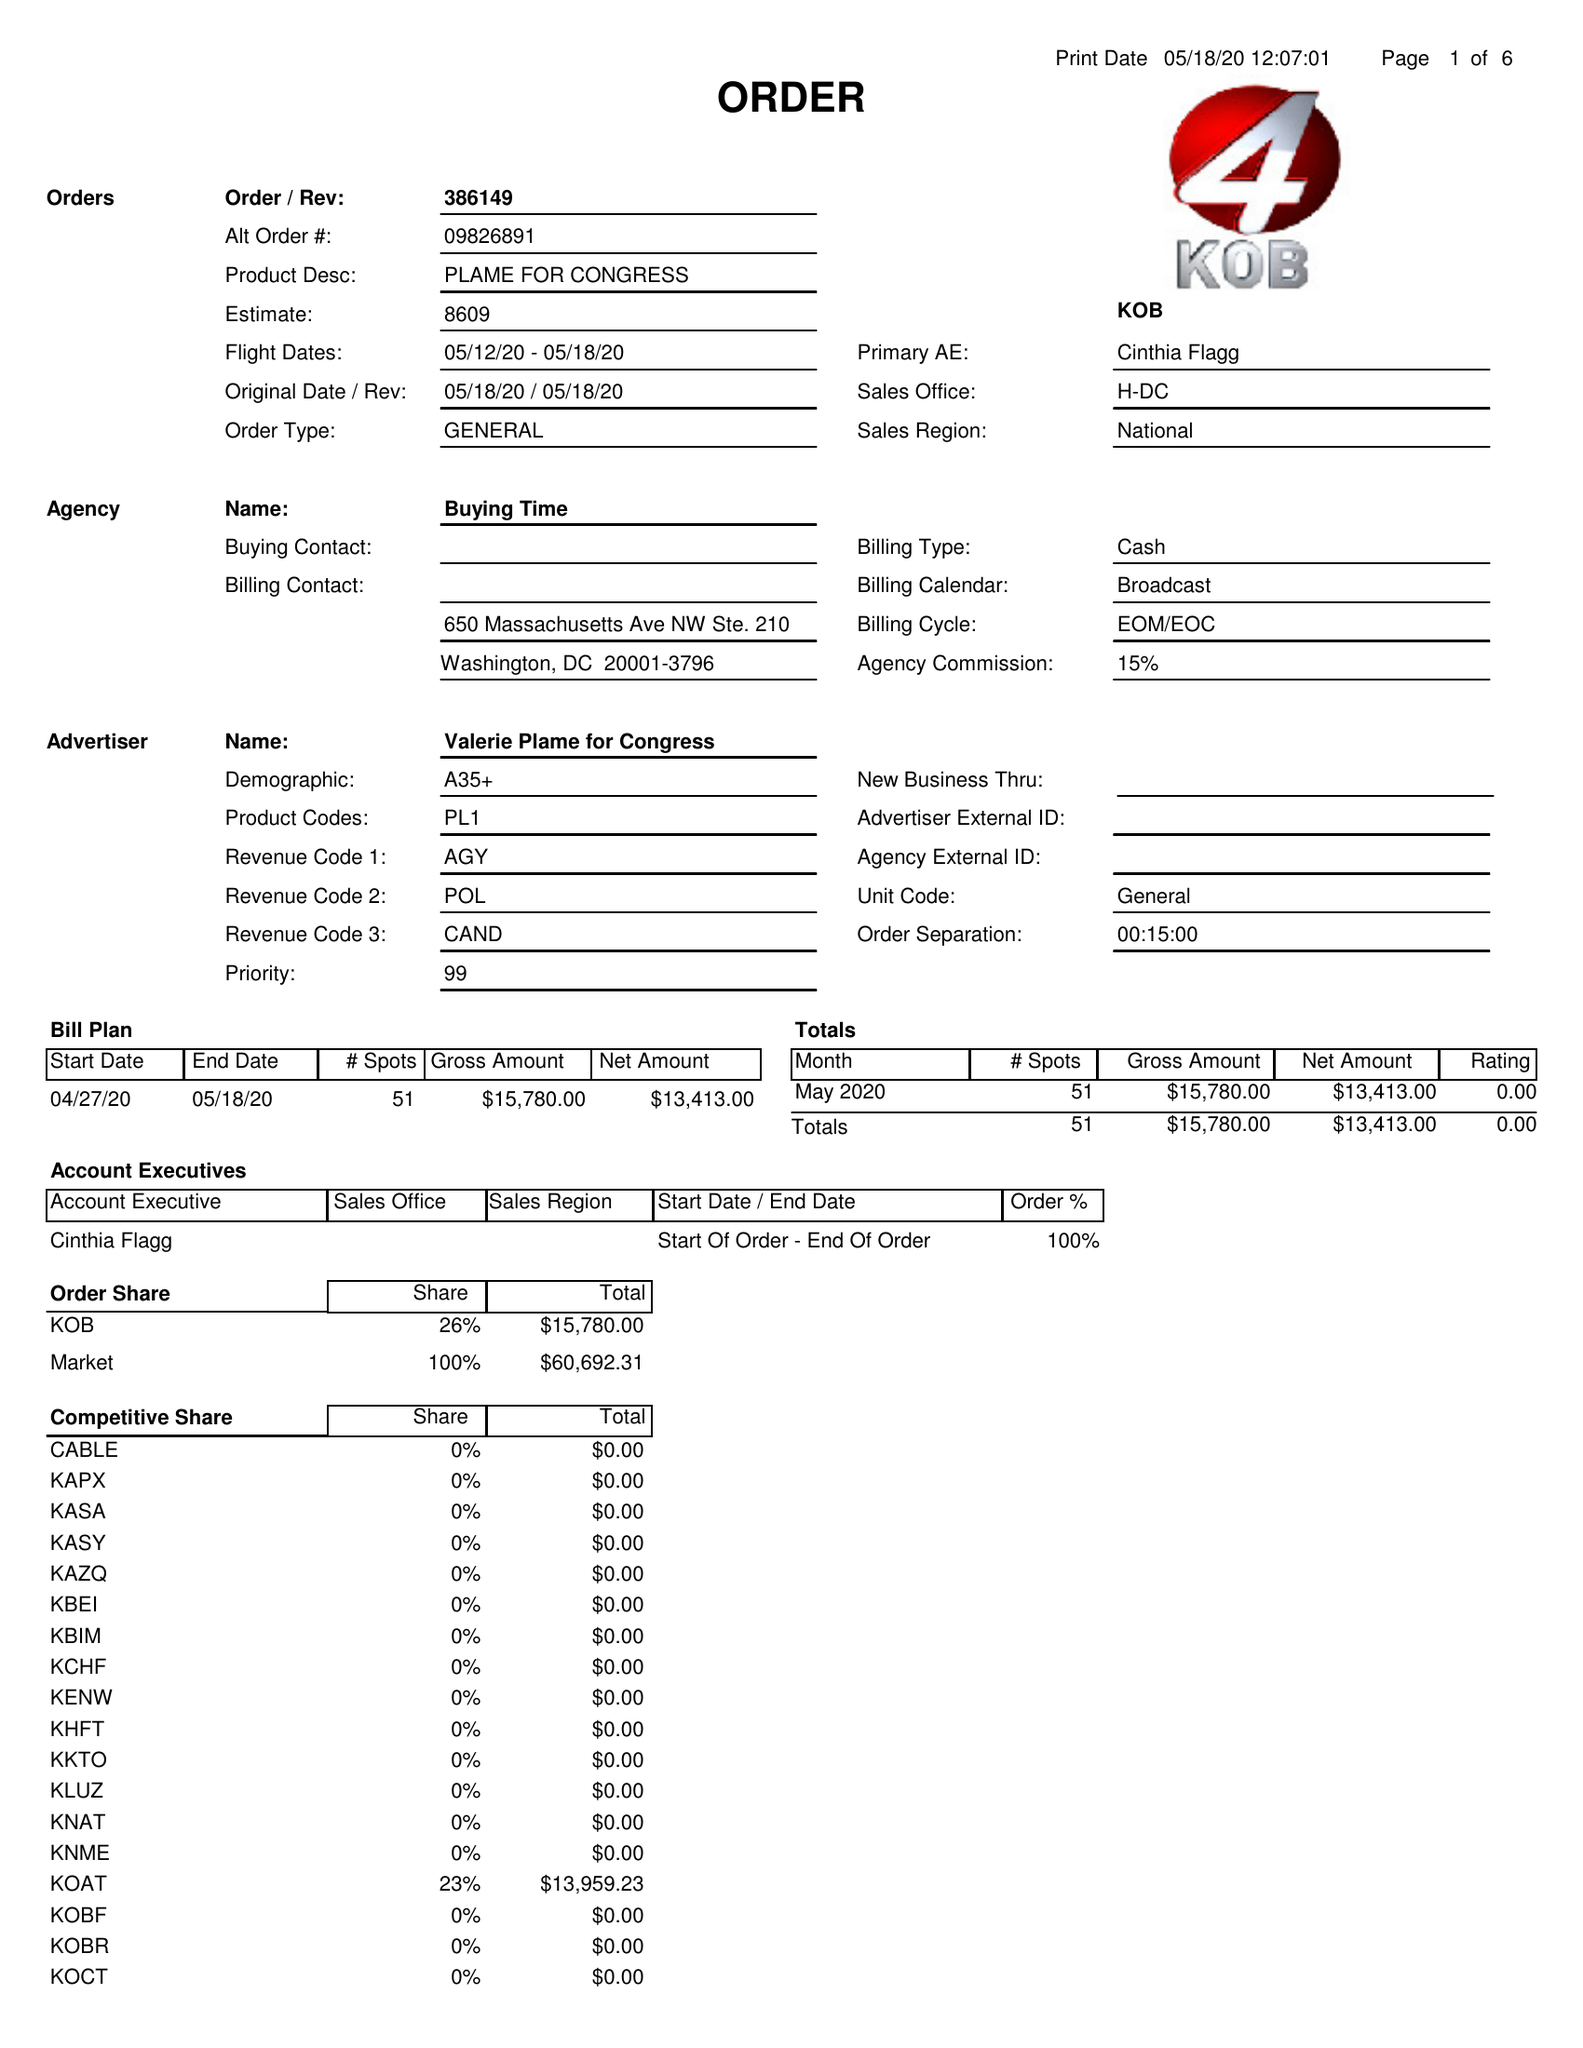What is the value for the gross_amount?
Answer the question using a single word or phrase. 15780.00 